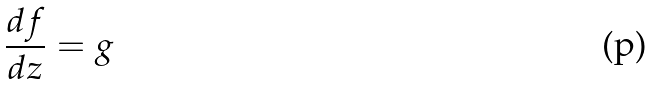Convert formula to latex. <formula><loc_0><loc_0><loc_500><loc_500>\frac { d f } { d z } = g</formula> 